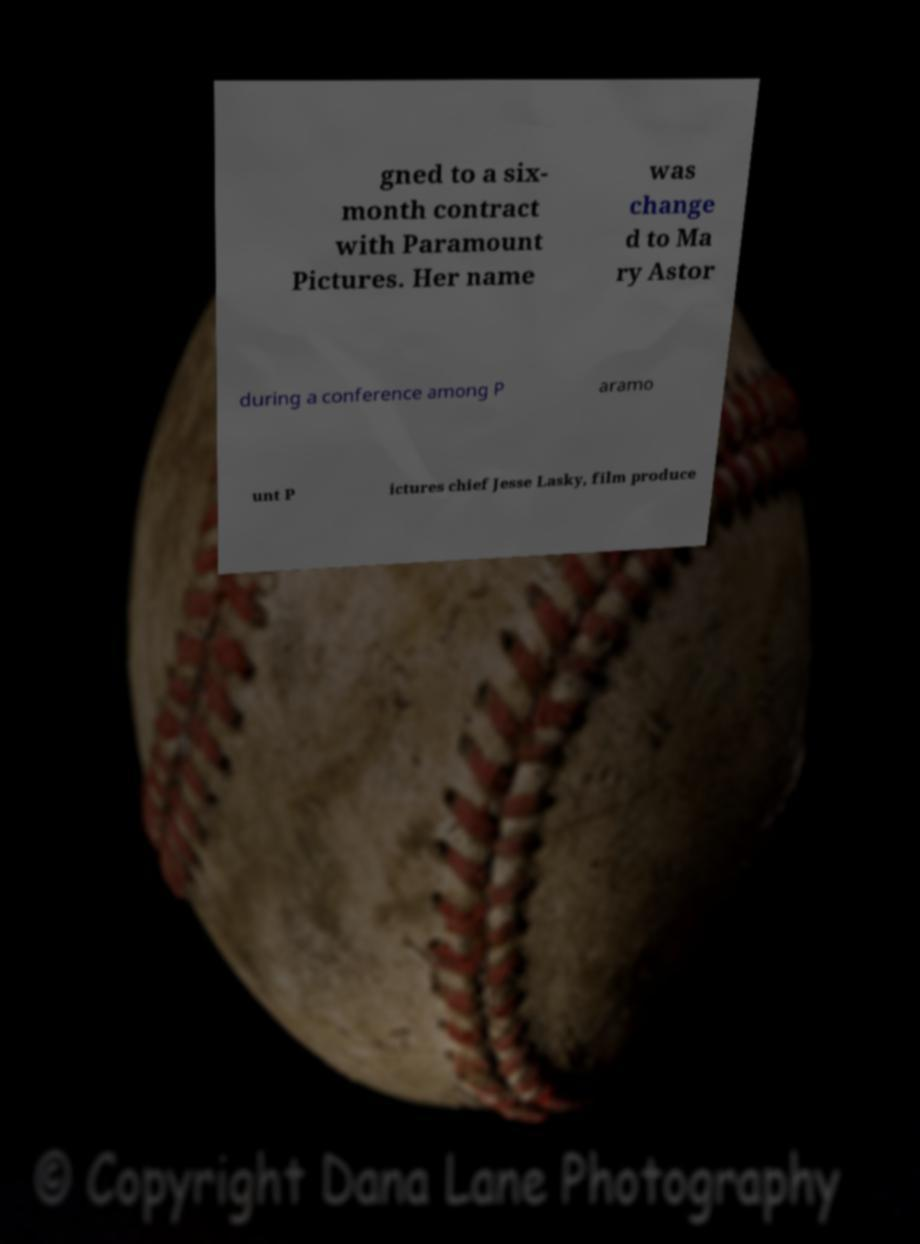There's text embedded in this image that I need extracted. Can you transcribe it verbatim? gned to a six- month contract with Paramount Pictures. Her name was change d to Ma ry Astor during a conference among P aramo unt P ictures chief Jesse Lasky, film produce 